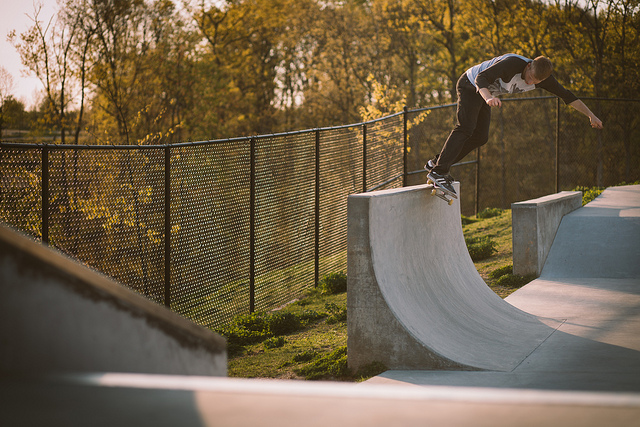How many people are there? There is 1 person in the image, captured in a dynamic pose while skateboarding on a ramp. 